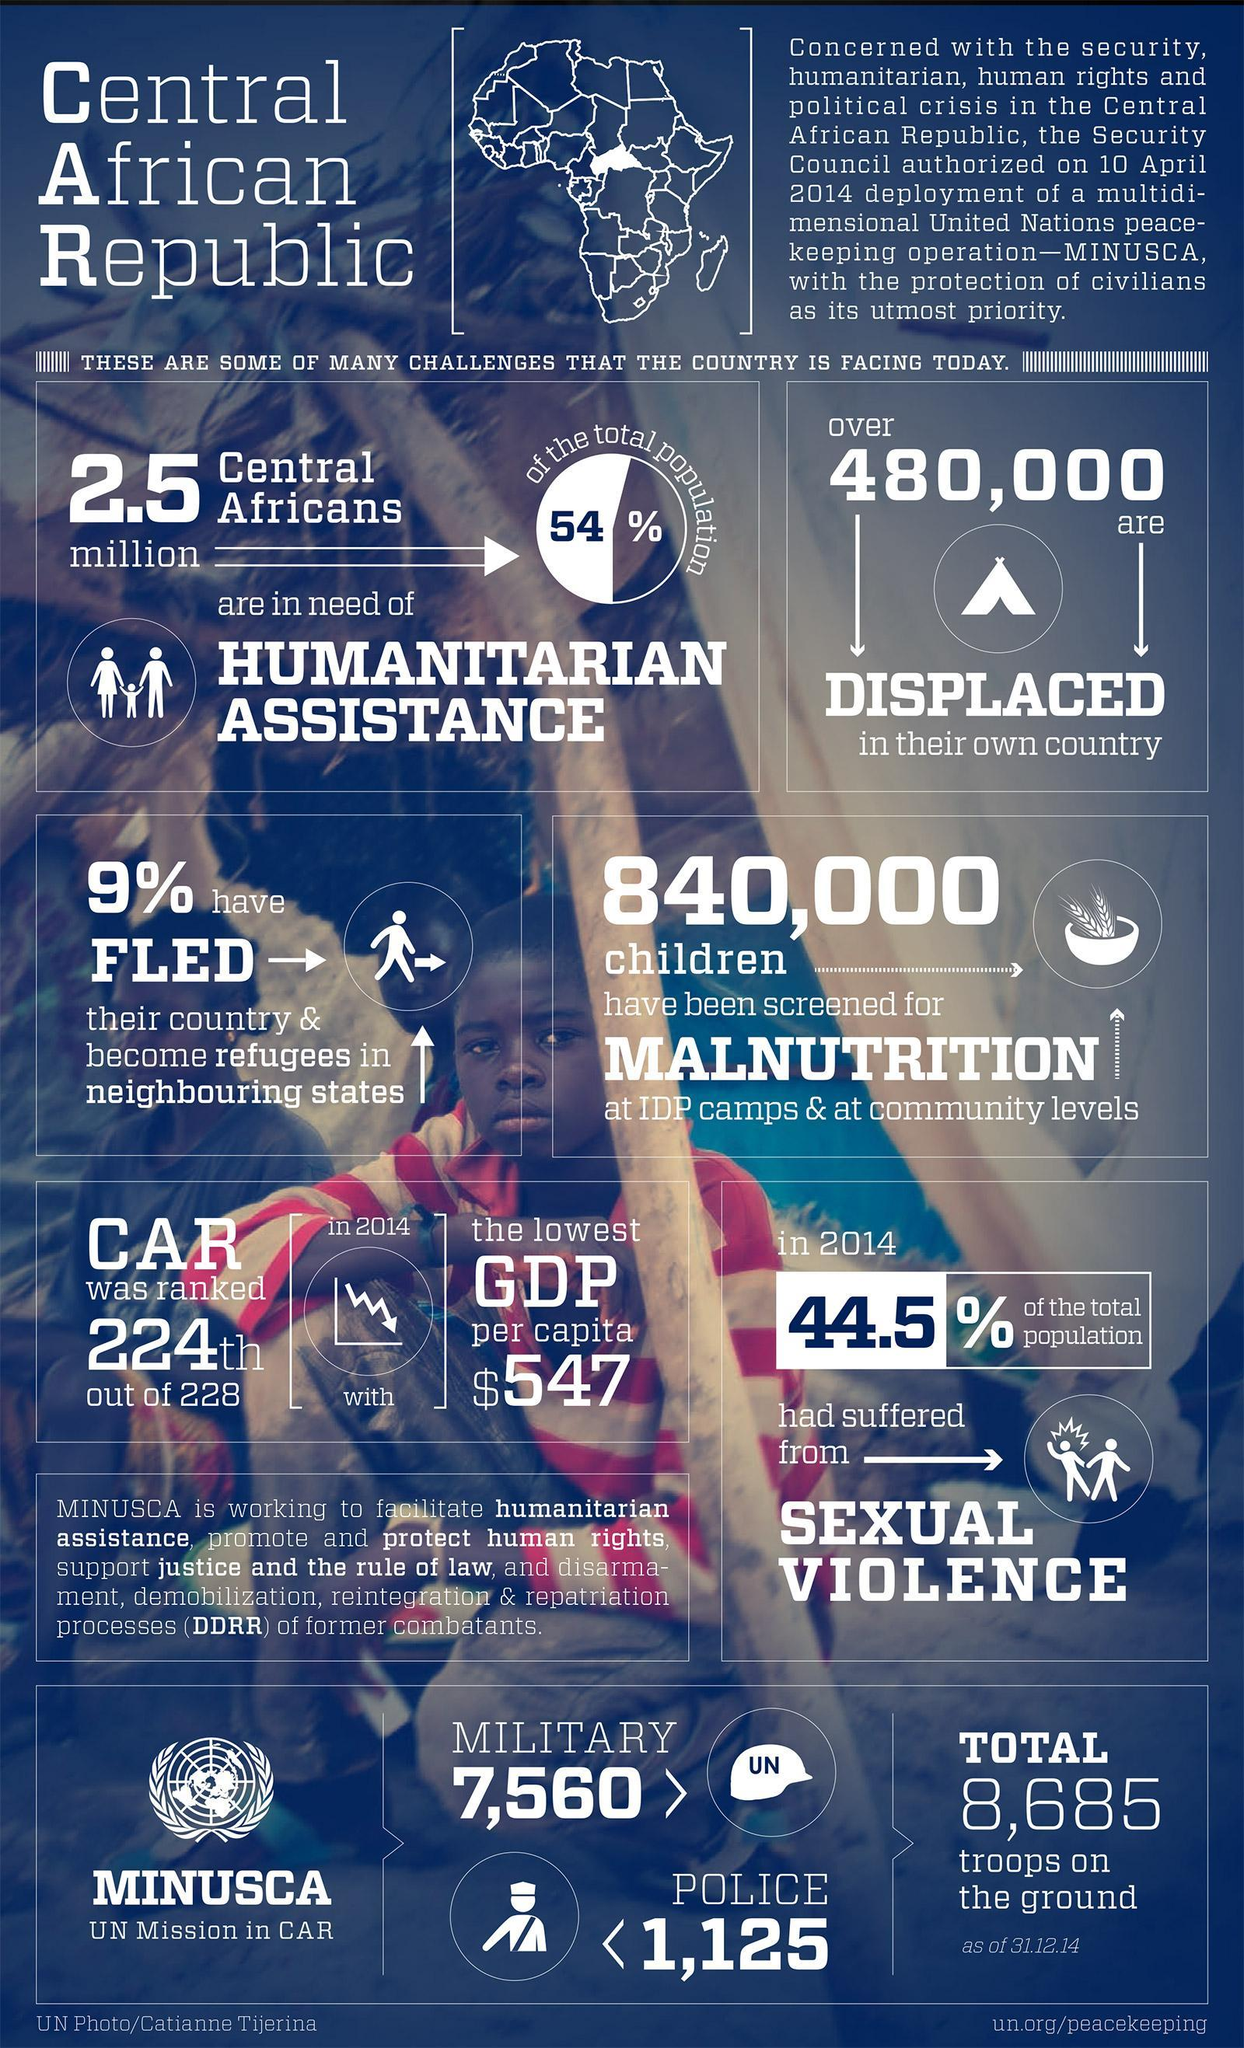What percentage of the population suffered sexual violence in 2014?
Answer the question with a short phrase. 44.5 How many Military troops are there in Central African Republic? 7,560 What is the total number of ground troops in CAR? 8,685 How many people are in need of humanitarian assistance in Central African Republic? 2.5 million Which is the peacekeeping mission by United Nations in Central African Republic? MINUSCA How many of the Central Africans are displaced in their own country? 480,000 What percentage of the Central Africans are living as refugees in neighbouring states? 9% How many children were examined for malnutrition? 840,000 What was the GDP ranking of Central African Republic in 2014? 224th What was the GDP per capita of Central African Republic in 2014? 547 